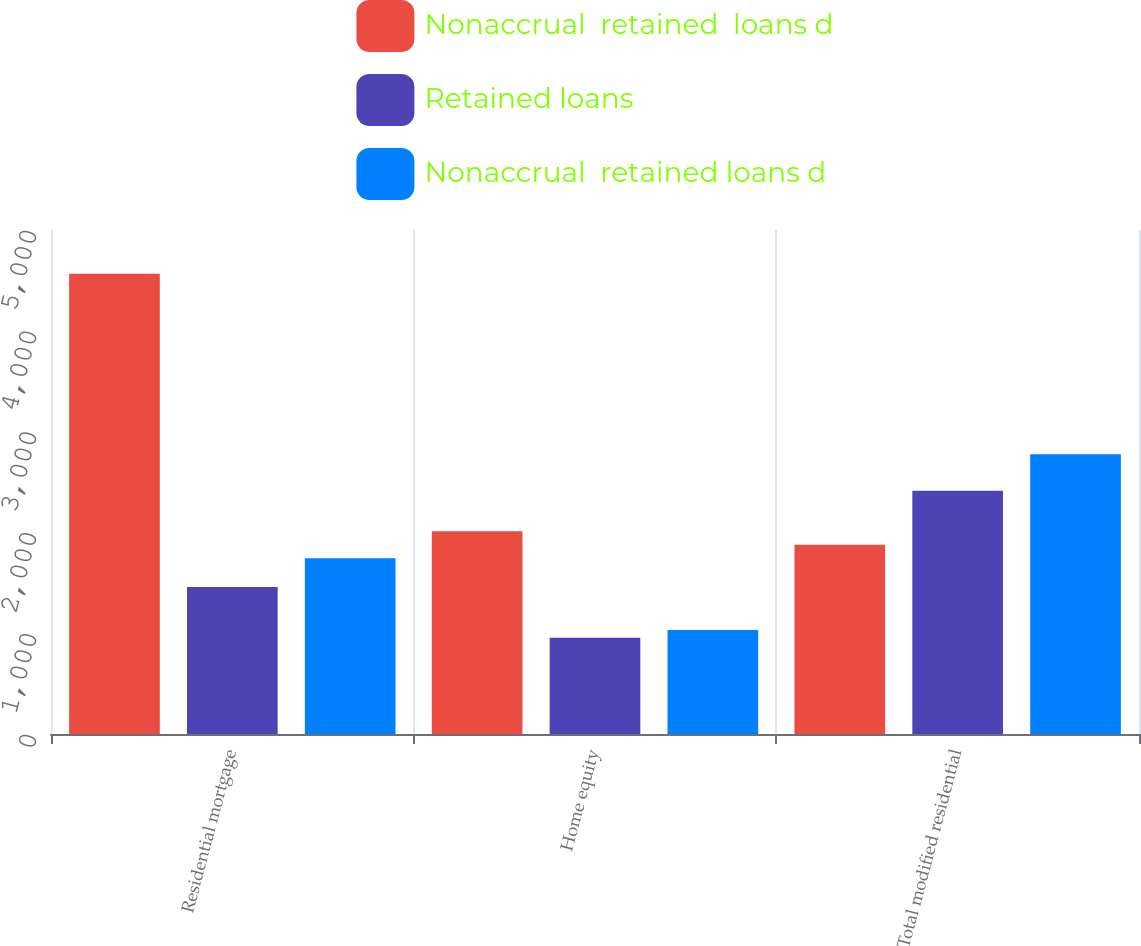<chart> <loc_0><loc_0><loc_500><loc_500><stacked_bar_chart><ecel><fcel>Residential mortgage<fcel>Home equity<fcel>Total modified residential<nl><fcel>Nonaccrual  retained  loans d<fcel>4565<fcel>2012<fcel>1877.5<nl><fcel>Retained loans<fcel>1459<fcel>955<fcel>2414<nl><fcel>Nonaccrual  retained loans d<fcel>1743<fcel>1032<fcel>2775<nl></chart> 